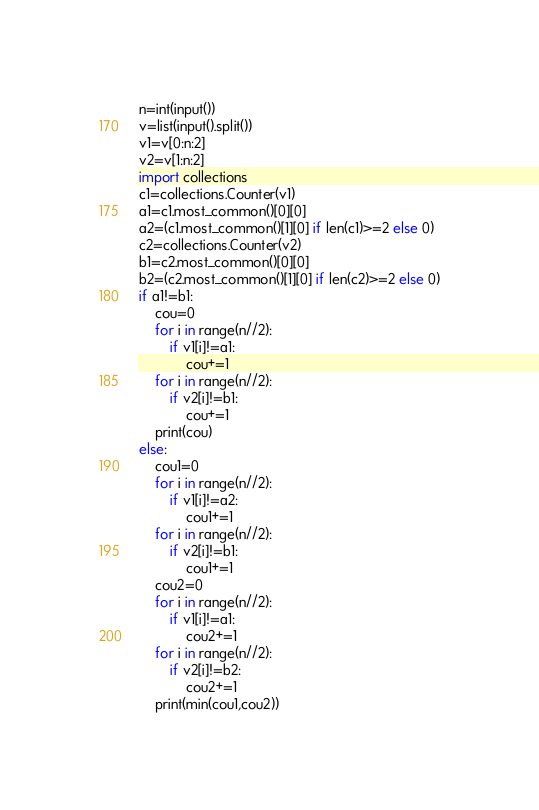Convert code to text. <code><loc_0><loc_0><loc_500><loc_500><_Python_>n=int(input())
v=list(input().split())
v1=v[0:n:2]
v2=v[1:n:2]
import collections
c1=collections.Counter(v1)
a1=c1.most_common()[0][0]
a2=(c1.most_common()[1][0] if len(c1)>=2 else 0)
c2=collections.Counter(v2)
b1=c2.most_common()[0][0]
b2=(c2.most_common()[1][0] if len(c2)>=2 else 0)
if a1!=b1:
    cou=0
    for i in range(n//2):
        if v1[i]!=a1:
            cou+=1
    for i in range(n//2):
        if v2[i]!=b1:
            cou+=1
    print(cou)
else:
    cou1=0
    for i in range(n//2):
        if v1[i]!=a2:
            cou1+=1
    for i in range(n//2):
        if v2[i]!=b1:
            cou1+=1
    cou2=0
    for i in range(n//2):
        if v1[i]!=a1:
            cou2+=1
    for i in range(n//2):
        if v2[i]!=b2:
            cou2+=1
    print(min(cou1,cou2))
</code> 